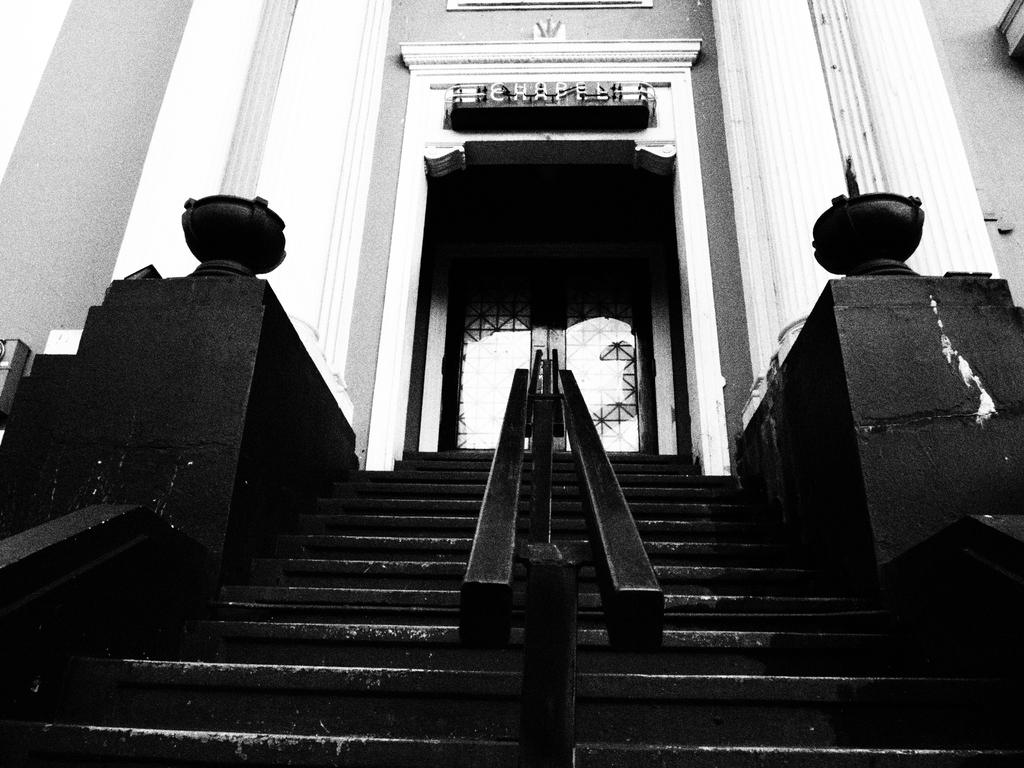What is the color scheme of the image? The image is black and white. What architectural feature can be seen in the image? There is a staircase in the image. What safety feature is present along the staircase? Railings are present in the image. What type of structure is visible in the image? Walls are visible in the image. What type of signage is present in the image? There is a name board in the image. What type of entrance or exit is present in the image? A door is present in the image. What type of feast is being prepared in the image? There is no indication of a feast being prepared in the image; it primarily features a staircase, railings, walls, a name board, and a door. What type of flesh is visible in the image? There is no flesh visible in the image; it is a black and white image of a staircase, railings, walls, a name board, and a door. 